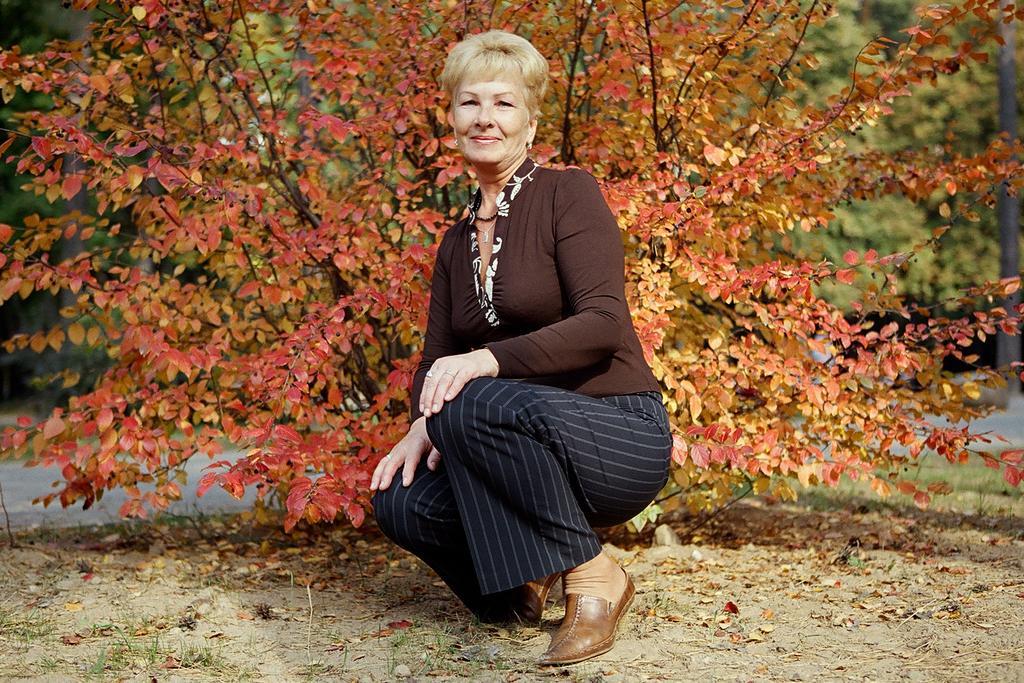Describe this image in one or two sentences. In this picture we can see a woman wearing brown t-shirt is sitting on the ground, smiling and giving a pose to the camera. In the background there is a tree with pink color leaves. 